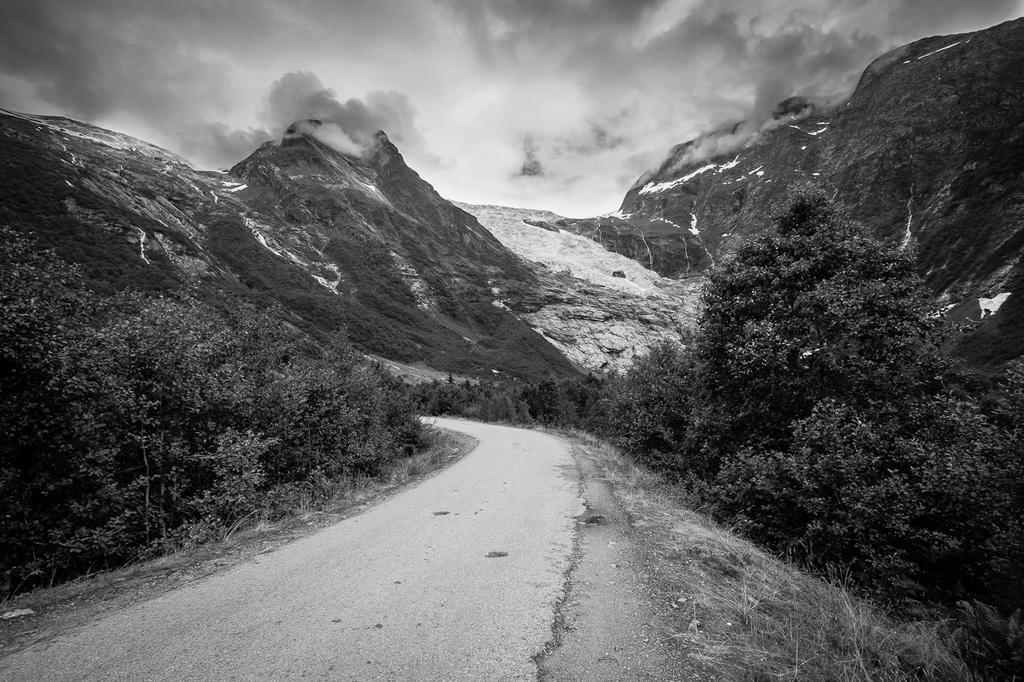In one or two sentences, can you explain what this image depicts? In this picture we can see a road, beside this road we can see trees and in the background we can see mountains, sky. 